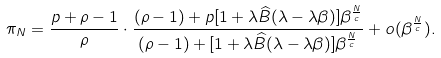<formula> <loc_0><loc_0><loc_500><loc_500>\pi _ { N } = \frac { p + \rho - 1 } { \rho } \cdot \frac { ( \rho - 1 ) + p [ 1 + \lambda \widehat { B } ( \lambda - \lambda \beta ) ] \beta ^ { \frac { N } { c } } } { ( \rho - 1 ) + [ 1 + \lambda \widehat { B } ( \lambda - \lambda \beta ) ] \beta ^ { \frac { N } { c } } } + o ( \beta ^ { \frac { N } { c } } ) .</formula> 